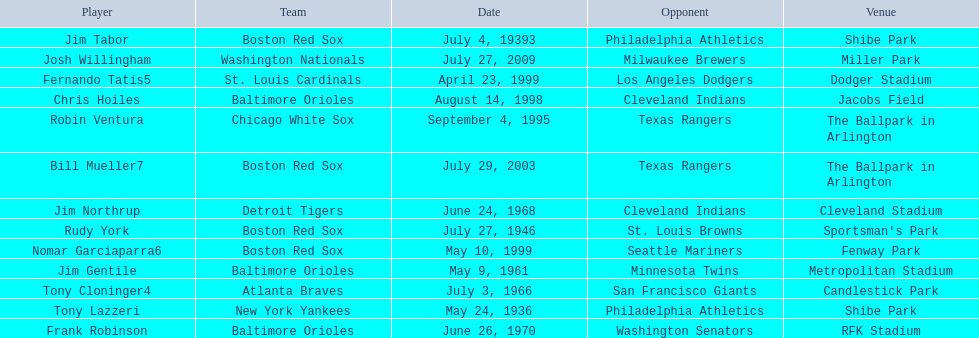Who was the opponent for the boston red sox on july 27, 1946? St. Louis Browns. 